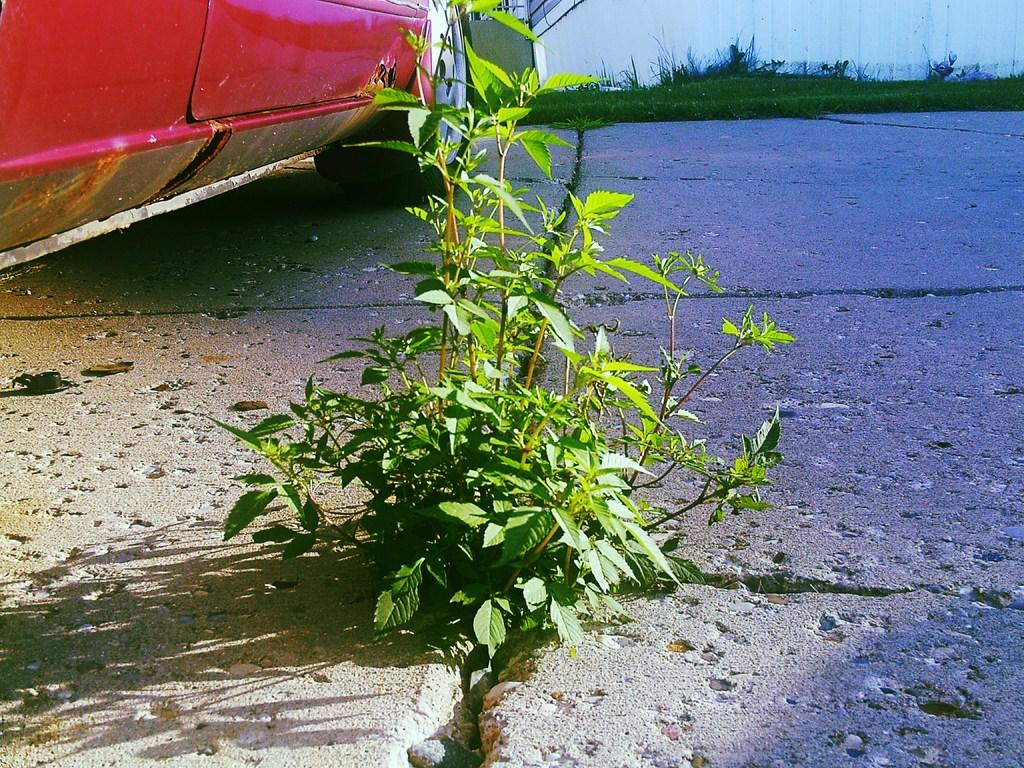What is the main subject of the image? There is a vehicle on the road in the image. Can you describe the surroundings of the vehicle? There are plants visible in the image. How many spiders are crawling on the vehicle in the image? There are no spiders visible in the image; it only shows a vehicle on the road and plants in the surroundings. 